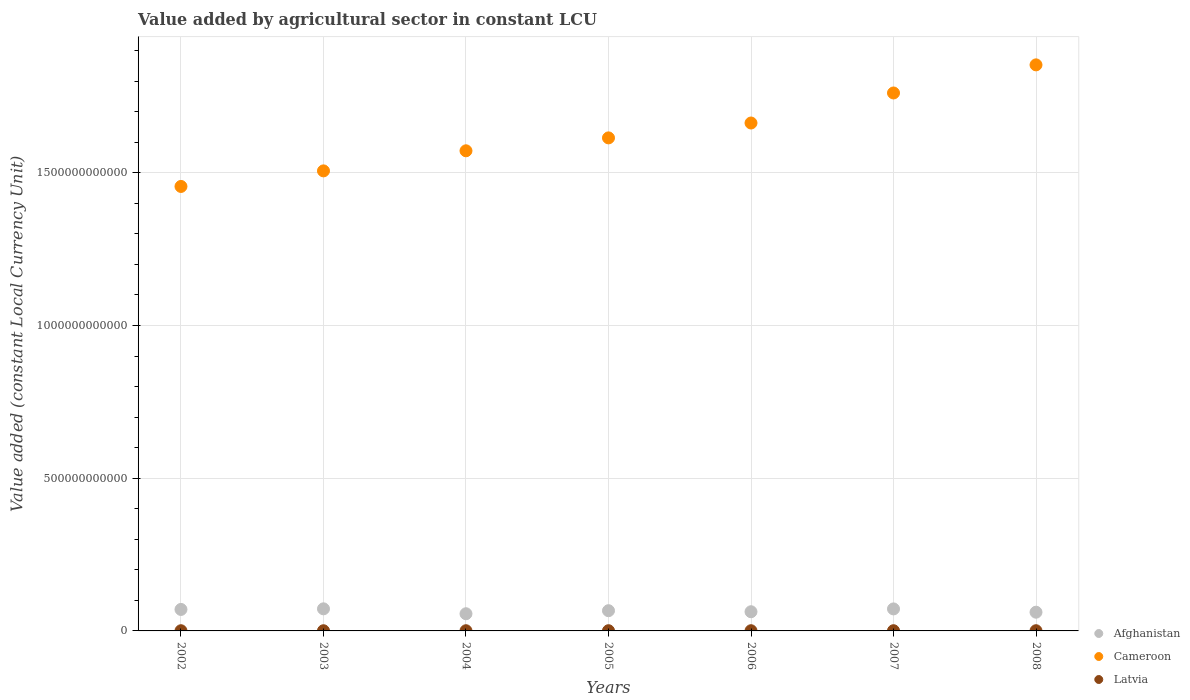What is the value added by agricultural sector in Cameroon in 2002?
Make the answer very short. 1.46e+12. Across all years, what is the maximum value added by agricultural sector in Latvia?
Provide a short and direct response. 6.98e+08. Across all years, what is the minimum value added by agricultural sector in Afghanistan?
Your answer should be very brief. 5.62e+1. In which year was the value added by agricultural sector in Afghanistan minimum?
Your answer should be very brief. 2004. What is the total value added by agricultural sector in Afghanistan in the graph?
Offer a very short reply. 4.61e+11. What is the difference between the value added by agricultural sector in Latvia in 2006 and that in 2007?
Your response must be concise. -5.31e+07. What is the difference between the value added by agricultural sector in Afghanistan in 2006 and the value added by agricultural sector in Cameroon in 2005?
Offer a terse response. -1.55e+12. What is the average value added by agricultural sector in Latvia per year?
Offer a terse response. 6.44e+08. In the year 2002, what is the difference between the value added by agricultural sector in Cameroon and value added by agricultural sector in Afghanistan?
Give a very brief answer. 1.39e+12. In how many years, is the value added by agricultural sector in Cameroon greater than 1300000000000 LCU?
Give a very brief answer. 7. What is the ratio of the value added by agricultural sector in Afghanistan in 2002 to that in 2005?
Make the answer very short. 1.06. Is the difference between the value added by agricultural sector in Cameroon in 2004 and 2007 greater than the difference between the value added by agricultural sector in Afghanistan in 2004 and 2007?
Keep it short and to the point. No. What is the difference between the highest and the second highest value added by agricultural sector in Latvia?
Make the answer very short. 2.53e+07. What is the difference between the highest and the lowest value added by agricultural sector in Afghanistan?
Provide a short and direct response. 1.61e+1. In how many years, is the value added by agricultural sector in Afghanistan greater than the average value added by agricultural sector in Afghanistan taken over all years?
Keep it short and to the point. 4. Is the sum of the value added by agricultural sector in Cameroon in 2006 and 2007 greater than the maximum value added by agricultural sector in Latvia across all years?
Keep it short and to the point. Yes. How many dotlines are there?
Make the answer very short. 3. How many years are there in the graph?
Give a very brief answer. 7. What is the difference between two consecutive major ticks on the Y-axis?
Make the answer very short. 5.00e+11. Does the graph contain any zero values?
Provide a succinct answer. No. Does the graph contain grids?
Your response must be concise. Yes. How many legend labels are there?
Your answer should be very brief. 3. How are the legend labels stacked?
Give a very brief answer. Vertical. What is the title of the graph?
Offer a terse response. Value added by agricultural sector in constant LCU. What is the label or title of the X-axis?
Your answer should be very brief. Years. What is the label or title of the Y-axis?
Offer a terse response. Value added (constant Local Currency Unit). What is the Value added (constant Local Currency Unit) in Afghanistan in 2002?
Keep it short and to the point. 7.04e+1. What is the Value added (constant Local Currency Unit) of Cameroon in 2002?
Give a very brief answer. 1.46e+12. What is the Value added (constant Local Currency Unit) in Latvia in 2002?
Offer a terse response. 6.17e+08. What is the Value added (constant Local Currency Unit) in Afghanistan in 2003?
Your answer should be very brief. 7.23e+1. What is the Value added (constant Local Currency Unit) in Cameroon in 2003?
Your answer should be very brief. 1.51e+12. What is the Value added (constant Local Currency Unit) in Latvia in 2003?
Offer a very short reply. 6.02e+08. What is the Value added (constant Local Currency Unit) in Afghanistan in 2004?
Make the answer very short. 5.62e+1. What is the Value added (constant Local Currency Unit) in Cameroon in 2004?
Your answer should be very brief. 1.57e+12. What is the Value added (constant Local Currency Unit) of Latvia in 2004?
Provide a succinct answer. 6.21e+08. What is the Value added (constant Local Currency Unit) of Afghanistan in 2005?
Offer a terse response. 6.62e+1. What is the Value added (constant Local Currency Unit) in Cameroon in 2005?
Provide a succinct answer. 1.61e+12. What is the Value added (constant Local Currency Unit) of Latvia in 2005?
Ensure brevity in your answer.  6.73e+08. What is the Value added (constant Local Currency Unit) of Afghanistan in 2006?
Ensure brevity in your answer.  6.28e+1. What is the Value added (constant Local Currency Unit) in Cameroon in 2006?
Keep it short and to the point. 1.66e+12. What is the Value added (constant Local Currency Unit) in Latvia in 2006?
Offer a terse response. 6.45e+08. What is the Value added (constant Local Currency Unit) of Afghanistan in 2007?
Your answer should be very brief. 7.21e+1. What is the Value added (constant Local Currency Unit) of Cameroon in 2007?
Keep it short and to the point. 1.76e+12. What is the Value added (constant Local Currency Unit) of Latvia in 2007?
Provide a short and direct response. 6.98e+08. What is the Value added (constant Local Currency Unit) of Afghanistan in 2008?
Your response must be concise. 6.13e+1. What is the Value added (constant Local Currency Unit) in Cameroon in 2008?
Provide a succinct answer. 1.85e+12. What is the Value added (constant Local Currency Unit) of Latvia in 2008?
Ensure brevity in your answer.  6.52e+08. Across all years, what is the maximum Value added (constant Local Currency Unit) in Afghanistan?
Offer a very short reply. 7.23e+1. Across all years, what is the maximum Value added (constant Local Currency Unit) in Cameroon?
Keep it short and to the point. 1.85e+12. Across all years, what is the maximum Value added (constant Local Currency Unit) in Latvia?
Offer a very short reply. 6.98e+08. Across all years, what is the minimum Value added (constant Local Currency Unit) of Afghanistan?
Keep it short and to the point. 5.62e+1. Across all years, what is the minimum Value added (constant Local Currency Unit) of Cameroon?
Make the answer very short. 1.46e+12. Across all years, what is the minimum Value added (constant Local Currency Unit) of Latvia?
Your answer should be very brief. 6.02e+08. What is the total Value added (constant Local Currency Unit) of Afghanistan in the graph?
Make the answer very short. 4.61e+11. What is the total Value added (constant Local Currency Unit) in Cameroon in the graph?
Make the answer very short. 1.14e+13. What is the total Value added (constant Local Currency Unit) in Latvia in the graph?
Make the answer very short. 4.51e+09. What is the difference between the Value added (constant Local Currency Unit) in Afghanistan in 2002 and that in 2003?
Your answer should be compact. -1.97e+09. What is the difference between the Value added (constant Local Currency Unit) in Cameroon in 2002 and that in 2003?
Provide a succinct answer. -5.10e+1. What is the difference between the Value added (constant Local Currency Unit) in Latvia in 2002 and that in 2003?
Your answer should be compact. 1.46e+07. What is the difference between the Value added (constant Local Currency Unit) of Afghanistan in 2002 and that in 2004?
Make the answer very short. 1.41e+1. What is the difference between the Value added (constant Local Currency Unit) of Cameroon in 2002 and that in 2004?
Provide a succinct answer. -1.17e+11. What is the difference between the Value added (constant Local Currency Unit) of Latvia in 2002 and that in 2004?
Offer a very short reply. -4.43e+06. What is the difference between the Value added (constant Local Currency Unit) in Afghanistan in 2002 and that in 2005?
Provide a short and direct response. 4.16e+09. What is the difference between the Value added (constant Local Currency Unit) of Cameroon in 2002 and that in 2005?
Make the answer very short. -1.59e+11. What is the difference between the Value added (constant Local Currency Unit) in Latvia in 2002 and that in 2005?
Your response must be concise. -5.60e+07. What is the difference between the Value added (constant Local Currency Unit) in Afghanistan in 2002 and that in 2006?
Your response must be concise. 7.54e+09. What is the difference between the Value added (constant Local Currency Unit) in Cameroon in 2002 and that in 2006?
Give a very brief answer. -2.08e+11. What is the difference between the Value added (constant Local Currency Unit) of Latvia in 2002 and that in 2006?
Keep it short and to the point. -2.82e+07. What is the difference between the Value added (constant Local Currency Unit) of Afghanistan in 2002 and that in 2007?
Provide a short and direct response. -1.69e+09. What is the difference between the Value added (constant Local Currency Unit) of Cameroon in 2002 and that in 2007?
Keep it short and to the point. -3.06e+11. What is the difference between the Value added (constant Local Currency Unit) in Latvia in 2002 and that in 2007?
Provide a short and direct response. -8.13e+07. What is the difference between the Value added (constant Local Currency Unit) of Afghanistan in 2002 and that in 2008?
Ensure brevity in your answer.  9.06e+09. What is the difference between the Value added (constant Local Currency Unit) of Cameroon in 2002 and that in 2008?
Provide a short and direct response. -3.98e+11. What is the difference between the Value added (constant Local Currency Unit) of Latvia in 2002 and that in 2008?
Provide a short and direct response. -3.53e+07. What is the difference between the Value added (constant Local Currency Unit) of Afghanistan in 2003 and that in 2004?
Ensure brevity in your answer.  1.61e+1. What is the difference between the Value added (constant Local Currency Unit) of Cameroon in 2003 and that in 2004?
Give a very brief answer. -6.58e+1. What is the difference between the Value added (constant Local Currency Unit) of Latvia in 2003 and that in 2004?
Provide a succinct answer. -1.90e+07. What is the difference between the Value added (constant Local Currency Unit) of Afghanistan in 2003 and that in 2005?
Provide a short and direct response. 6.13e+09. What is the difference between the Value added (constant Local Currency Unit) of Cameroon in 2003 and that in 2005?
Ensure brevity in your answer.  -1.08e+11. What is the difference between the Value added (constant Local Currency Unit) of Latvia in 2003 and that in 2005?
Make the answer very short. -7.05e+07. What is the difference between the Value added (constant Local Currency Unit) of Afghanistan in 2003 and that in 2006?
Your answer should be compact. 9.51e+09. What is the difference between the Value added (constant Local Currency Unit) of Cameroon in 2003 and that in 2006?
Keep it short and to the point. -1.57e+11. What is the difference between the Value added (constant Local Currency Unit) in Latvia in 2003 and that in 2006?
Offer a terse response. -4.28e+07. What is the difference between the Value added (constant Local Currency Unit) of Afghanistan in 2003 and that in 2007?
Give a very brief answer. 2.80e+08. What is the difference between the Value added (constant Local Currency Unit) of Cameroon in 2003 and that in 2007?
Provide a short and direct response. -2.55e+11. What is the difference between the Value added (constant Local Currency Unit) of Latvia in 2003 and that in 2007?
Offer a very short reply. -9.59e+07. What is the difference between the Value added (constant Local Currency Unit) of Afghanistan in 2003 and that in 2008?
Offer a very short reply. 1.10e+1. What is the difference between the Value added (constant Local Currency Unit) of Cameroon in 2003 and that in 2008?
Provide a succinct answer. -3.47e+11. What is the difference between the Value added (constant Local Currency Unit) in Latvia in 2003 and that in 2008?
Offer a terse response. -4.98e+07. What is the difference between the Value added (constant Local Currency Unit) in Afghanistan in 2004 and that in 2005?
Make the answer very short. -9.96e+09. What is the difference between the Value added (constant Local Currency Unit) of Cameroon in 2004 and that in 2005?
Offer a very short reply. -4.23e+1. What is the difference between the Value added (constant Local Currency Unit) of Latvia in 2004 and that in 2005?
Offer a terse response. -5.15e+07. What is the difference between the Value added (constant Local Currency Unit) of Afghanistan in 2004 and that in 2006?
Ensure brevity in your answer.  -6.57e+09. What is the difference between the Value added (constant Local Currency Unit) of Cameroon in 2004 and that in 2006?
Provide a succinct answer. -9.10e+1. What is the difference between the Value added (constant Local Currency Unit) in Latvia in 2004 and that in 2006?
Give a very brief answer. -2.38e+07. What is the difference between the Value added (constant Local Currency Unit) in Afghanistan in 2004 and that in 2007?
Provide a short and direct response. -1.58e+1. What is the difference between the Value added (constant Local Currency Unit) in Cameroon in 2004 and that in 2007?
Offer a very short reply. -1.89e+11. What is the difference between the Value added (constant Local Currency Unit) of Latvia in 2004 and that in 2007?
Make the answer very short. -7.69e+07. What is the difference between the Value added (constant Local Currency Unit) of Afghanistan in 2004 and that in 2008?
Provide a short and direct response. -5.06e+09. What is the difference between the Value added (constant Local Currency Unit) of Cameroon in 2004 and that in 2008?
Keep it short and to the point. -2.81e+11. What is the difference between the Value added (constant Local Currency Unit) of Latvia in 2004 and that in 2008?
Your response must be concise. -3.08e+07. What is the difference between the Value added (constant Local Currency Unit) of Afghanistan in 2005 and that in 2006?
Offer a terse response. 3.38e+09. What is the difference between the Value added (constant Local Currency Unit) in Cameroon in 2005 and that in 2006?
Keep it short and to the point. -4.87e+1. What is the difference between the Value added (constant Local Currency Unit) in Latvia in 2005 and that in 2006?
Offer a very short reply. 2.78e+07. What is the difference between the Value added (constant Local Currency Unit) in Afghanistan in 2005 and that in 2007?
Your answer should be very brief. -5.85e+09. What is the difference between the Value added (constant Local Currency Unit) of Cameroon in 2005 and that in 2007?
Offer a terse response. -1.47e+11. What is the difference between the Value added (constant Local Currency Unit) of Latvia in 2005 and that in 2007?
Ensure brevity in your answer.  -2.53e+07. What is the difference between the Value added (constant Local Currency Unit) of Afghanistan in 2005 and that in 2008?
Keep it short and to the point. 4.90e+09. What is the difference between the Value added (constant Local Currency Unit) of Cameroon in 2005 and that in 2008?
Give a very brief answer. -2.39e+11. What is the difference between the Value added (constant Local Currency Unit) of Latvia in 2005 and that in 2008?
Ensure brevity in your answer.  2.07e+07. What is the difference between the Value added (constant Local Currency Unit) in Afghanistan in 2006 and that in 2007?
Keep it short and to the point. -9.23e+09. What is the difference between the Value added (constant Local Currency Unit) in Cameroon in 2006 and that in 2007?
Your answer should be compact. -9.84e+1. What is the difference between the Value added (constant Local Currency Unit) of Latvia in 2006 and that in 2007?
Offer a very short reply. -5.31e+07. What is the difference between the Value added (constant Local Currency Unit) in Afghanistan in 2006 and that in 2008?
Ensure brevity in your answer.  1.52e+09. What is the difference between the Value added (constant Local Currency Unit) of Cameroon in 2006 and that in 2008?
Provide a succinct answer. -1.90e+11. What is the difference between the Value added (constant Local Currency Unit) of Latvia in 2006 and that in 2008?
Offer a very short reply. -7.08e+06. What is the difference between the Value added (constant Local Currency Unit) of Afghanistan in 2007 and that in 2008?
Keep it short and to the point. 1.07e+1. What is the difference between the Value added (constant Local Currency Unit) in Cameroon in 2007 and that in 2008?
Offer a terse response. -9.20e+1. What is the difference between the Value added (constant Local Currency Unit) in Latvia in 2007 and that in 2008?
Make the answer very short. 4.60e+07. What is the difference between the Value added (constant Local Currency Unit) in Afghanistan in 2002 and the Value added (constant Local Currency Unit) in Cameroon in 2003?
Your answer should be compact. -1.44e+12. What is the difference between the Value added (constant Local Currency Unit) of Afghanistan in 2002 and the Value added (constant Local Currency Unit) of Latvia in 2003?
Provide a succinct answer. 6.98e+1. What is the difference between the Value added (constant Local Currency Unit) of Cameroon in 2002 and the Value added (constant Local Currency Unit) of Latvia in 2003?
Provide a succinct answer. 1.45e+12. What is the difference between the Value added (constant Local Currency Unit) of Afghanistan in 2002 and the Value added (constant Local Currency Unit) of Cameroon in 2004?
Provide a succinct answer. -1.50e+12. What is the difference between the Value added (constant Local Currency Unit) of Afghanistan in 2002 and the Value added (constant Local Currency Unit) of Latvia in 2004?
Provide a succinct answer. 6.97e+1. What is the difference between the Value added (constant Local Currency Unit) of Cameroon in 2002 and the Value added (constant Local Currency Unit) of Latvia in 2004?
Keep it short and to the point. 1.45e+12. What is the difference between the Value added (constant Local Currency Unit) in Afghanistan in 2002 and the Value added (constant Local Currency Unit) in Cameroon in 2005?
Provide a short and direct response. -1.54e+12. What is the difference between the Value added (constant Local Currency Unit) of Afghanistan in 2002 and the Value added (constant Local Currency Unit) of Latvia in 2005?
Offer a terse response. 6.97e+1. What is the difference between the Value added (constant Local Currency Unit) in Cameroon in 2002 and the Value added (constant Local Currency Unit) in Latvia in 2005?
Provide a succinct answer. 1.45e+12. What is the difference between the Value added (constant Local Currency Unit) in Afghanistan in 2002 and the Value added (constant Local Currency Unit) in Cameroon in 2006?
Give a very brief answer. -1.59e+12. What is the difference between the Value added (constant Local Currency Unit) of Afghanistan in 2002 and the Value added (constant Local Currency Unit) of Latvia in 2006?
Ensure brevity in your answer.  6.97e+1. What is the difference between the Value added (constant Local Currency Unit) in Cameroon in 2002 and the Value added (constant Local Currency Unit) in Latvia in 2006?
Provide a short and direct response. 1.45e+12. What is the difference between the Value added (constant Local Currency Unit) in Afghanistan in 2002 and the Value added (constant Local Currency Unit) in Cameroon in 2007?
Ensure brevity in your answer.  -1.69e+12. What is the difference between the Value added (constant Local Currency Unit) in Afghanistan in 2002 and the Value added (constant Local Currency Unit) in Latvia in 2007?
Ensure brevity in your answer.  6.97e+1. What is the difference between the Value added (constant Local Currency Unit) in Cameroon in 2002 and the Value added (constant Local Currency Unit) in Latvia in 2007?
Ensure brevity in your answer.  1.45e+12. What is the difference between the Value added (constant Local Currency Unit) of Afghanistan in 2002 and the Value added (constant Local Currency Unit) of Cameroon in 2008?
Your response must be concise. -1.78e+12. What is the difference between the Value added (constant Local Currency Unit) in Afghanistan in 2002 and the Value added (constant Local Currency Unit) in Latvia in 2008?
Ensure brevity in your answer.  6.97e+1. What is the difference between the Value added (constant Local Currency Unit) of Cameroon in 2002 and the Value added (constant Local Currency Unit) of Latvia in 2008?
Provide a succinct answer. 1.45e+12. What is the difference between the Value added (constant Local Currency Unit) of Afghanistan in 2003 and the Value added (constant Local Currency Unit) of Cameroon in 2004?
Offer a terse response. -1.50e+12. What is the difference between the Value added (constant Local Currency Unit) in Afghanistan in 2003 and the Value added (constant Local Currency Unit) in Latvia in 2004?
Your response must be concise. 7.17e+1. What is the difference between the Value added (constant Local Currency Unit) of Cameroon in 2003 and the Value added (constant Local Currency Unit) of Latvia in 2004?
Give a very brief answer. 1.51e+12. What is the difference between the Value added (constant Local Currency Unit) in Afghanistan in 2003 and the Value added (constant Local Currency Unit) in Cameroon in 2005?
Your answer should be very brief. -1.54e+12. What is the difference between the Value added (constant Local Currency Unit) of Afghanistan in 2003 and the Value added (constant Local Currency Unit) of Latvia in 2005?
Your response must be concise. 7.17e+1. What is the difference between the Value added (constant Local Currency Unit) of Cameroon in 2003 and the Value added (constant Local Currency Unit) of Latvia in 2005?
Your answer should be very brief. 1.51e+12. What is the difference between the Value added (constant Local Currency Unit) in Afghanistan in 2003 and the Value added (constant Local Currency Unit) in Cameroon in 2006?
Provide a succinct answer. -1.59e+12. What is the difference between the Value added (constant Local Currency Unit) of Afghanistan in 2003 and the Value added (constant Local Currency Unit) of Latvia in 2006?
Offer a very short reply. 7.17e+1. What is the difference between the Value added (constant Local Currency Unit) of Cameroon in 2003 and the Value added (constant Local Currency Unit) of Latvia in 2006?
Ensure brevity in your answer.  1.51e+12. What is the difference between the Value added (constant Local Currency Unit) of Afghanistan in 2003 and the Value added (constant Local Currency Unit) of Cameroon in 2007?
Your answer should be very brief. -1.69e+12. What is the difference between the Value added (constant Local Currency Unit) of Afghanistan in 2003 and the Value added (constant Local Currency Unit) of Latvia in 2007?
Keep it short and to the point. 7.16e+1. What is the difference between the Value added (constant Local Currency Unit) of Cameroon in 2003 and the Value added (constant Local Currency Unit) of Latvia in 2007?
Give a very brief answer. 1.51e+12. What is the difference between the Value added (constant Local Currency Unit) in Afghanistan in 2003 and the Value added (constant Local Currency Unit) in Cameroon in 2008?
Keep it short and to the point. -1.78e+12. What is the difference between the Value added (constant Local Currency Unit) of Afghanistan in 2003 and the Value added (constant Local Currency Unit) of Latvia in 2008?
Provide a succinct answer. 7.17e+1. What is the difference between the Value added (constant Local Currency Unit) in Cameroon in 2003 and the Value added (constant Local Currency Unit) in Latvia in 2008?
Provide a succinct answer. 1.51e+12. What is the difference between the Value added (constant Local Currency Unit) of Afghanistan in 2004 and the Value added (constant Local Currency Unit) of Cameroon in 2005?
Provide a succinct answer. -1.56e+12. What is the difference between the Value added (constant Local Currency Unit) in Afghanistan in 2004 and the Value added (constant Local Currency Unit) in Latvia in 2005?
Your answer should be very brief. 5.56e+1. What is the difference between the Value added (constant Local Currency Unit) in Cameroon in 2004 and the Value added (constant Local Currency Unit) in Latvia in 2005?
Your answer should be very brief. 1.57e+12. What is the difference between the Value added (constant Local Currency Unit) in Afghanistan in 2004 and the Value added (constant Local Currency Unit) in Cameroon in 2006?
Keep it short and to the point. -1.61e+12. What is the difference between the Value added (constant Local Currency Unit) of Afghanistan in 2004 and the Value added (constant Local Currency Unit) of Latvia in 2006?
Make the answer very short. 5.56e+1. What is the difference between the Value added (constant Local Currency Unit) in Cameroon in 2004 and the Value added (constant Local Currency Unit) in Latvia in 2006?
Give a very brief answer. 1.57e+12. What is the difference between the Value added (constant Local Currency Unit) in Afghanistan in 2004 and the Value added (constant Local Currency Unit) in Cameroon in 2007?
Ensure brevity in your answer.  -1.71e+12. What is the difference between the Value added (constant Local Currency Unit) in Afghanistan in 2004 and the Value added (constant Local Currency Unit) in Latvia in 2007?
Offer a very short reply. 5.56e+1. What is the difference between the Value added (constant Local Currency Unit) in Cameroon in 2004 and the Value added (constant Local Currency Unit) in Latvia in 2007?
Provide a succinct answer. 1.57e+12. What is the difference between the Value added (constant Local Currency Unit) in Afghanistan in 2004 and the Value added (constant Local Currency Unit) in Cameroon in 2008?
Ensure brevity in your answer.  -1.80e+12. What is the difference between the Value added (constant Local Currency Unit) in Afghanistan in 2004 and the Value added (constant Local Currency Unit) in Latvia in 2008?
Make the answer very short. 5.56e+1. What is the difference between the Value added (constant Local Currency Unit) in Cameroon in 2004 and the Value added (constant Local Currency Unit) in Latvia in 2008?
Offer a very short reply. 1.57e+12. What is the difference between the Value added (constant Local Currency Unit) in Afghanistan in 2005 and the Value added (constant Local Currency Unit) in Cameroon in 2006?
Provide a short and direct response. -1.60e+12. What is the difference between the Value added (constant Local Currency Unit) of Afghanistan in 2005 and the Value added (constant Local Currency Unit) of Latvia in 2006?
Give a very brief answer. 6.56e+1. What is the difference between the Value added (constant Local Currency Unit) in Cameroon in 2005 and the Value added (constant Local Currency Unit) in Latvia in 2006?
Ensure brevity in your answer.  1.61e+12. What is the difference between the Value added (constant Local Currency Unit) in Afghanistan in 2005 and the Value added (constant Local Currency Unit) in Cameroon in 2007?
Your answer should be compact. -1.70e+12. What is the difference between the Value added (constant Local Currency Unit) of Afghanistan in 2005 and the Value added (constant Local Currency Unit) of Latvia in 2007?
Offer a terse response. 6.55e+1. What is the difference between the Value added (constant Local Currency Unit) of Cameroon in 2005 and the Value added (constant Local Currency Unit) of Latvia in 2007?
Offer a terse response. 1.61e+12. What is the difference between the Value added (constant Local Currency Unit) in Afghanistan in 2005 and the Value added (constant Local Currency Unit) in Cameroon in 2008?
Make the answer very short. -1.79e+12. What is the difference between the Value added (constant Local Currency Unit) in Afghanistan in 2005 and the Value added (constant Local Currency Unit) in Latvia in 2008?
Make the answer very short. 6.56e+1. What is the difference between the Value added (constant Local Currency Unit) of Cameroon in 2005 and the Value added (constant Local Currency Unit) of Latvia in 2008?
Ensure brevity in your answer.  1.61e+12. What is the difference between the Value added (constant Local Currency Unit) in Afghanistan in 2006 and the Value added (constant Local Currency Unit) in Cameroon in 2007?
Your answer should be very brief. -1.70e+12. What is the difference between the Value added (constant Local Currency Unit) of Afghanistan in 2006 and the Value added (constant Local Currency Unit) of Latvia in 2007?
Keep it short and to the point. 6.21e+1. What is the difference between the Value added (constant Local Currency Unit) of Cameroon in 2006 and the Value added (constant Local Currency Unit) of Latvia in 2007?
Ensure brevity in your answer.  1.66e+12. What is the difference between the Value added (constant Local Currency Unit) in Afghanistan in 2006 and the Value added (constant Local Currency Unit) in Cameroon in 2008?
Keep it short and to the point. -1.79e+12. What is the difference between the Value added (constant Local Currency Unit) in Afghanistan in 2006 and the Value added (constant Local Currency Unit) in Latvia in 2008?
Offer a terse response. 6.22e+1. What is the difference between the Value added (constant Local Currency Unit) of Cameroon in 2006 and the Value added (constant Local Currency Unit) of Latvia in 2008?
Make the answer very short. 1.66e+12. What is the difference between the Value added (constant Local Currency Unit) in Afghanistan in 2007 and the Value added (constant Local Currency Unit) in Cameroon in 2008?
Offer a terse response. -1.78e+12. What is the difference between the Value added (constant Local Currency Unit) of Afghanistan in 2007 and the Value added (constant Local Currency Unit) of Latvia in 2008?
Offer a terse response. 7.14e+1. What is the difference between the Value added (constant Local Currency Unit) of Cameroon in 2007 and the Value added (constant Local Currency Unit) of Latvia in 2008?
Make the answer very short. 1.76e+12. What is the average Value added (constant Local Currency Unit) in Afghanistan per year?
Ensure brevity in your answer.  6.59e+1. What is the average Value added (constant Local Currency Unit) of Cameroon per year?
Keep it short and to the point. 1.63e+12. What is the average Value added (constant Local Currency Unit) of Latvia per year?
Provide a succinct answer. 6.44e+08. In the year 2002, what is the difference between the Value added (constant Local Currency Unit) of Afghanistan and Value added (constant Local Currency Unit) of Cameroon?
Offer a very short reply. -1.39e+12. In the year 2002, what is the difference between the Value added (constant Local Currency Unit) of Afghanistan and Value added (constant Local Currency Unit) of Latvia?
Your response must be concise. 6.97e+1. In the year 2002, what is the difference between the Value added (constant Local Currency Unit) in Cameroon and Value added (constant Local Currency Unit) in Latvia?
Keep it short and to the point. 1.45e+12. In the year 2003, what is the difference between the Value added (constant Local Currency Unit) of Afghanistan and Value added (constant Local Currency Unit) of Cameroon?
Offer a very short reply. -1.43e+12. In the year 2003, what is the difference between the Value added (constant Local Currency Unit) in Afghanistan and Value added (constant Local Currency Unit) in Latvia?
Your answer should be very brief. 7.17e+1. In the year 2003, what is the difference between the Value added (constant Local Currency Unit) in Cameroon and Value added (constant Local Currency Unit) in Latvia?
Your answer should be very brief. 1.51e+12. In the year 2004, what is the difference between the Value added (constant Local Currency Unit) in Afghanistan and Value added (constant Local Currency Unit) in Cameroon?
Give a very brief answer. -1.52e+12. In the year 2004, what is the difference between the Value added (constant Local Currency Unit) in Afghanistan and Value added (constant Local Currency Unit) in Latvia?
Offer a terse response. 5.56e+1. In the year 2004, what is the difference between the Value added (constant Local Currency Unit) of Cameroon and Value added (constant Local Currency Unit) of Latvia?
Give a very brief answer. 1.57e+12. In the year 2005, what is the difference between the Value added (constant Local Currency Unit) in Afghanistan and Value added (constant Local Currency Unit) in Cameroon?
Give a very brief answer. -1.55e+12. In the year 2005, what is the difference between the Value added (constant Local Currency Unit) of Afghanistan and Value added (constant Local Currency Unit) of Latvia?
Your response must be concise. 6.55e+1. In the year 2005, what is the difference between the Value added (constant Local Currency Unit) of Cameroon and Value added (constant Local Currency Unit) of Latvia?
Your response must be concise. 1.61e+12. In the year 2006, what is the difference between the Value added (constant Local Currency Unit) of Afghanistan and Value added (constant Local Currency Unit) of Cameroon?
Your response must be concise. -1.60e+12. In the year 2006, what is the difference between the Value added (constant Local Currency Unit) in Afghanistan and Value added (constant Local Currency Unit) in Latvia?
Provide a short and direct response. 6.22e+1. In the year 2006, what is the difference between the Value added (constant Local Currency Unit) in Cameroon and Value added (constant Local Currency Unit) in Latvia?
Your response must be concise. 1.66e+12. In the year 2007, what is the difference between the Value added (constant Local Currency Unit) in Afghanistan and Value added (constant Local Currency Unit) in Cameroon?
Your answer should be compact. -1.69e+12. In the year 2007, what is the difference between the Value added (constant Local Currency Unit) of Afghanistan and Value added (constant Local Currency Unit) of Latvia?
Your answer should be very brief. 7.14e+1. In the year 2007, what is the difference between the Value added (constant Local Currency Unit) of Cameroon and Value added (constant Local Currency Unit) of Latvia?
Offer a very short reply. 1.76e+12. In the year 2008, what is the difference between the Value added (constant Local Currency Unit) in Afghanistan and Value added (constant Local Currency Unit) in Cameroon?
Your answer should be compact. -1.79e+12. In the year 2008, what is the difference between the Value added (constant Local Currency Unit) in Afghanistan and Value added (constant Local Currency Unit) in Latvia?
Keep it short and to the point. 6.07e+1. In the year 2008, what is the difference between the Value added (constant Local Currency Unit) in Cameroon and Value added (constant Local Currency Unit) in Latvia?
Your answer should be very brief. 1.85e+12. What is the ratio of the Value added (constant Local Currency Unit) of Afghanistan in 2002 to that in 2003?
Keep it short and to the point. 0.97. What is the ratio of the Value added (constant Local Currency Unit) in Cameroon in 2002 to that in 2003?
Give a very brief answer. 0.97. What is the ratio of the Value added (constant Local Currency Unit) of Latvia in 2002 to that in 2003?
Give a very brief answer. 1.02. What is the ratio of the Value added (constant Local Currency Unit) in Afghanistan in 2002 to that in 2004?
Give a very brief answer. 1.25. What is the ratio of the Value added (constant Local Currency Unit) of Cameroon in 2002 to that in 2004?
Give a very brief answer. 0.93. What is the ratio of the Value added (constant Local Currency Unit) in Latvia in 2002 to that in 2004?
Your answer should be compact. 0.99. What is the ratio of the Value added (constant Local Currency Unit) of Afghanistan in 2002 to that in 2005?
Offer a very short reply. 1.06. What is the ratio of the Value added (constant Local Currency Unit) in Cameroon in 2002 to that in 2005?
Ensure brevity in your answer.  0.9. What is the ratio of the Value added (constant Local Currency Unit) of Latvia in 2002 to that in 2005?
Provide a succinct answer. 0.92. What is the ratio of the Value added (constant Local Currency Unit) in Afghanistan in 2002 to that in 2006?
Provide a short and direct response. 1.12. What is the ratio of the Value added (constant Local Currency Unit) of Cameroon in 2002 to that in 2006?
Ensure brevity in your answer.  0.88. What is the ratio of the Value added (constant Local Currency Unit) in Latvia in 2002 to that in 2006?
Your answer should be compact. 0.96. What is the ratio of the Value added (constant Local Currency Unit) of Afghanistan in 2002 to that in 2007?
Provide a short and direct response. 0.98. What is the ratio of the Value added (constant Local Currency Unit) in Cameroon in 2002 to that in 2007?
Provide a short and direct response. 0.83. What is the ratio of the Value added (constant Local Currency Unit) of Latvia in 2002 to that in 2007?
Your answer should be very brief. 0.88. What is the ratio of the Value added (constant Local Currency Unit) in Afghanistan in 2002 to that in 2008?
Offer a very short reply. 1.15. What is the ratio of the Value added (constant Local Currency Unit) in Cameroon in 2002 to that in 2008?
Provide a short and direct response. 0.79. What is the ratio of the Value added (constant Local Currency Unit) of Latvia in 2002 to that in 2008?
Your response must be concise. 0.95. What is the ratio of the Value added (constant Local Currency Unit) in Afghanistan in 2003 to that in 2004?
Offer a terse response. 1.29. What is the ratio of the Value added (constant Local Currency Unit) in Cameroon in 2003 to that in 2004?
Your answer should be compact. 0.96. What is the ratio of the Value added (constant Local Currency Unit) in Latvia in 2003 to that in 2004?
Offer a very short reply. 0.97. What is the ratio of the Value added (constant Local Currency Unit) of Afghanistan in 2003 to that in 2005?
Offer a terse response. 1.09. What is the ratio of the Value added (constant Local Currency Unit) of Cameroon in 2003 to that in 2005?
Make the answer very short. 0.93. What is the ratio of the Value added (constant Local Currency Unit) in Latvia in 2003 to that in 2005?
Provide a short and direct response. 0.9. What is the ratio of the Value added (constant Local Currency Unit) of Afghanistan in 2003 to that in 2006?
Your answer should be compact. 1.15. What is the ratio of the Value added (constant Local Currency Unit) of Cameroon in 2003 to that in 2006?
Provide a short and direct response. 0.91. What is the ratio of the Value added (constant Local Currency Unit) of Latvia in 2003 to that in 2006?
Offer a very short reply. 0.93. What is the ratio of the Value added (constant Local Currency Unit) of Afghanistan in 2003 to that in 2007?
Offer a terse response. 1. What is the ratio of the Value added (constant Local Currency Unit) of Cameroon in 2003 to that in 2007?
Provide a succinct answer. 0.86. What is the ratio of the Value added (constant Local Currency Unit) in Latvia in 2003 to that in 2007?
Offer a terse response. 0.86. What is the ratio of the Value added (constant Local Currency Unit) of Afghanistan in 2003 to that in 2008?
Provide a short and direct response. 1.18. What is the ratio of the Value added (constant Local Currency Unit) of Cameroon in 2003 to that in 2008?
Give a very brief answer. 0.81. What is the ratio of the Value added (constant Local Currency Unit) in Latvia in 2003 to that in 2008?
Make the answer very short. 0.92. What is the ratio of the Value added (constant Local Currency Unit) in Afghanistan in 2004 to that in 2005?
Offer a very short reply. 0.85. What is the ratio of the Value added (constant Local Currency Unit) of Cameroon in 2004 to that in 2005?
Your answer should be very brief. 0.97. What is the ratio of the Value added (constant Local Currency Unit) in Latvia in 2004 to that in 2005?
Ensure brevity in your answer.  0.92. What is the ratio of the Value added (constant Local Currency Unit) in Afghanistan in 2004 to that in 2006?
Make the answer very short. 0.9. What is the ratio of the Value added (constant Local Currency Unit) of Cameroon in 2004 to that in 2006?
Provide a short and direct response. 0.95. What is the ratio of the Value added (constant Local Currency Unit) of Latvia in 2004 to that in 2006?
Offer a very short reply. 0.96. What is the ratio of the Value added (constant Local Currency Unit) of Afghanistan in 2004 to that in 2007?
Offer a very short reply. 0.78. What is the ratio of the Value added (constant Local Currency Unit) of Cameroon in 2004 to that in 2007?
Offer a very short reply. 0.89. What is the ratio of the Value added (constant Local Currency Unit) of Latvia in 2004 to that in 2007?
Offer a terse response. 0.89. What is the ratio of the Value added (constant Local Currency Unit) of Afghanistan in 2004 to that in 2008?
Provide a short and direct response. 0.92. What is the ratio of the Value added (constant Local Currency Unit) of Cameroon in 2004 to that in 2008?
Keep it short and to the point. 0.85. What is the ratio of the Value added (constant Local Currency Unit) of Latvia in 2004 to that in 2008?
Your answer should be very brief. 0.95. What is the ratio of the Value added (constant Local Currency Unit) of Afghanistan in 2005 to that in 2006?
Ensure brevity in your answer.  1.05. What is the ratio of the Value added (constant Local Currency Unit) in Cameroon in 2005 to that in 2006?
Make the answer very short. 0.97. What is the ratio of the Value added (constant Local Currency Unit) in Latvia in 2005 to that in 2006?
Ensure brevity in your answer.  1.04. What is the ratio of the Value added (constant Local Currency Unit) in Afghanistan in 2005 to that in 2007?
Your response must be concise. 0.92. What is the ratio of the Value added (constant Local Currency Unit) in Cameroon in 2005 to that in 2007?
Your answer should be compact. 0.92. What is the ratio of the Value added (constant Local Currency Unit) of Latvia in 2005 to that in 2007?
Provide a short and direct response. 0.96. What is the ratio of the Value added (constant Local Currency Unit) in Afghanistan in 2005 to that in 2008?
Give a very brief answer. 1.08. What is the ratio of the Value added (constant Local Currency Unit) in Cameroon in 2005 to that in 2008?
Offer a terse response. 0.87. What is the ratio of the Value added (constant Local Currency Unit) of Latvia in 2005 to that in 2008?
Offer a terse response. 1.03. What is the ratio of the Value added (constant Local Currency Unit) in Afghanistan in 2006 to that in 2007?
Provide a succinct answer. 0.87. What is the ratio of the Value added (constant Local Currency Unit) of Cameroon in 2006 to that in 2007?
Provide a short and direct response. 0.94. What is the ratio of the Value added (constant Local Currency Unit) in Latvia in 2006 to that in 2007?
Your answer should be compact. 0.92. What is the ratio of the Value added (constant Local Currency Unit) of Afghanistan in 2006 to that in 2008?
Provide a short and direct response. 1.02. What is the ratio of the Value added (constant Local Currency Unit) of Cameroon in 2006 to that in 2008?
Your answer should be very brief. 0.9. What is the ratio of the Value added (constant Local Currency Unit) of Latvia in 2006 to that in 2008?
Provide a succinct answer. 0.99. What is the ratio of the Value added (constant Local Currency Unit) in Afghanistan in 2007 to that in 2008?
Your answer should be very brief. 1.18. What is the ratio of the Value added (constant Local Currency Unit) in Cameroon in 2007 to that in 2008?
Your response must be concise. 0.95. What is the ratio of the Value added (constant Local Currency Unit) of Latvia in 2007 to that in 2008?
Make the answer very short. 1.07. What is the difference between the highest and the second highest Value added (constant Local Currency Unit) of Afghanistan?
Provide a succinct answer. 2.80e+08. What is the difference between the highest and the second highest Value added (constant Local Currency Unit) in Cameroon?
Your response must be concise. 9.20e+1. What is the difference between the highest and the second highest Value added (constant Local Currency Unit) of Latvia?
Your response must be concise. 2.53e+07. What is the difference between the highest and the lowest Value added (constant Local Currency Unit) in Afghanistan?
Offer a very short reply. 1.61e+1. What is the difference between the highest and the lowest Value added (constant Local Currency Unit) in Cameroon?
Offer a terse response. 3.98e+11. What is the difference between the highest and the lowest Value added (constant Local Currency Unit) in Latvia?
Give a very brief answer. 9.59e+07. 